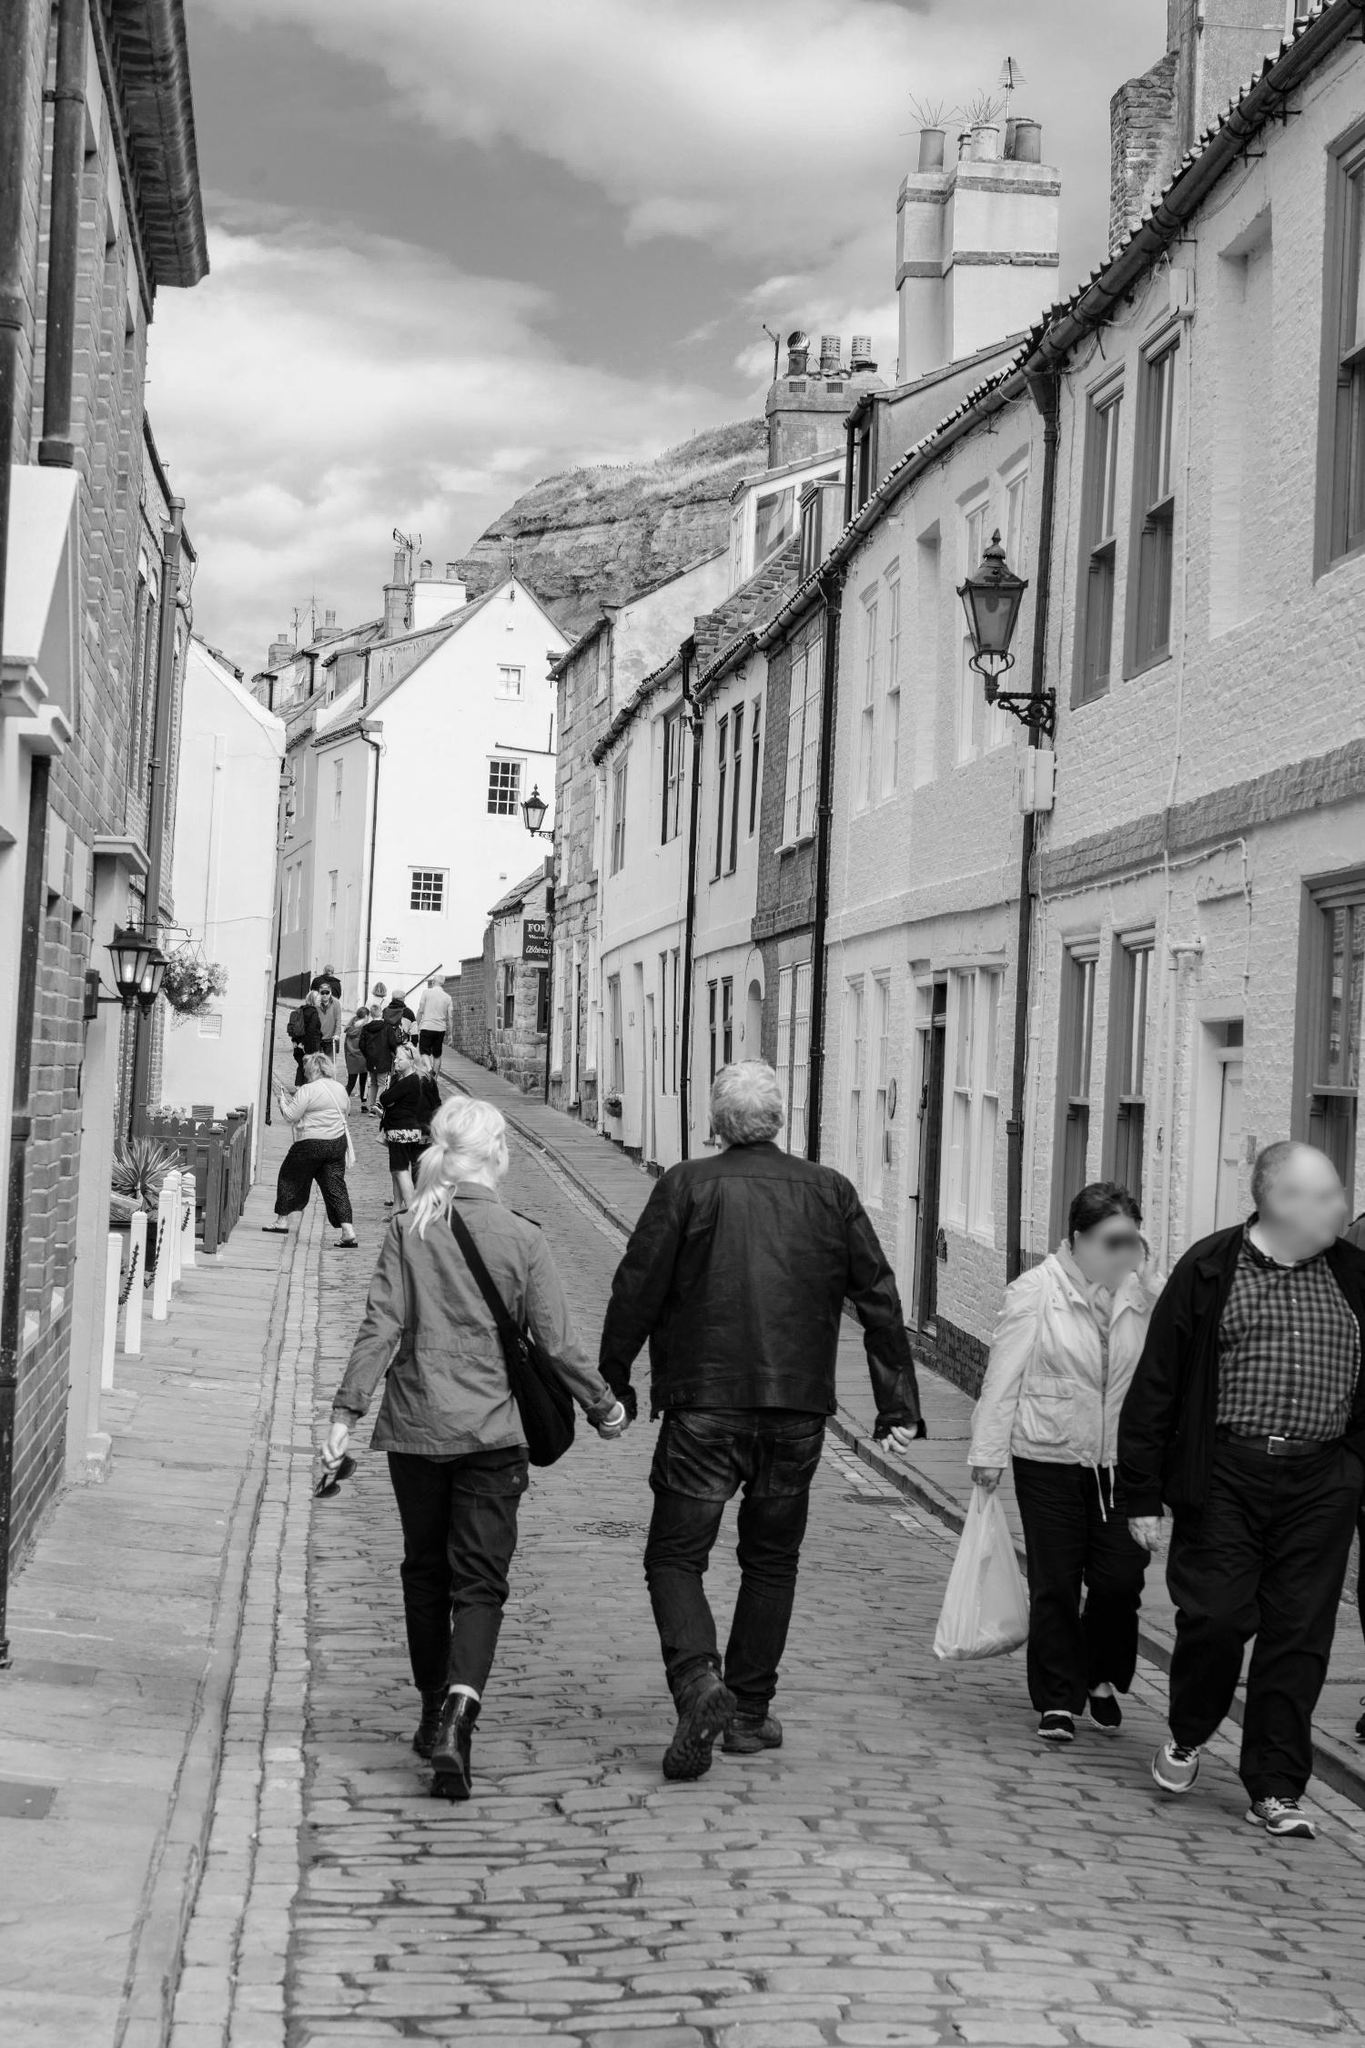Describe the following image. The image showcases a picturesque scene of a cobblestone street in a European town, rendered in black and white. Flanked by old buildings adorned with white walls and contrasting black roofs, the street slopes gently upwards, giving depth to the scene. The buildings exhibit a consistent architectural style, marked by black shutters that punctuate the white façades.

Life unfolds along the street as people go about their activities. Some are seen walking at a leisurely pace, enjoying their stroll, while others carry bags, likely from a shopping excursion. A few pedestrians have umbrellas, suggesting a light rain might have fallen or is expected.

Looming in the background atop a hill is a historic castle, hinting at the town's rich heritage. The presence of the castle, the serene cobblestone street, the individuals, and the uniform buildings come together to form a harmonious snapshot of everyday life in this quaint European town. The visual composition of the image conveys a peaceful and cohesive atmosphere. 